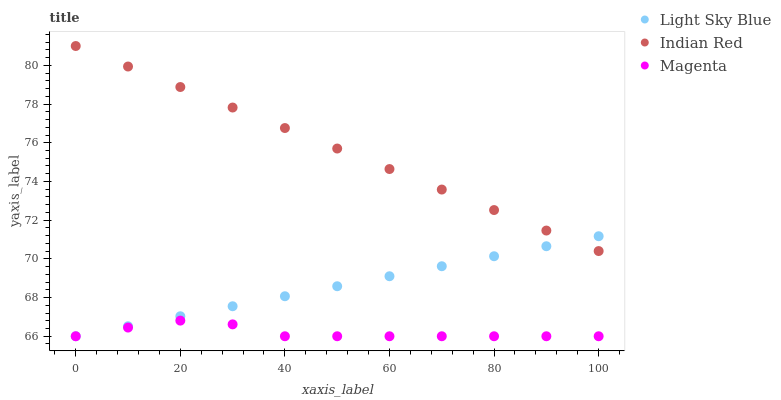Does Magenta have the minimum area under the curve?
Answer yes or no. Yes. Does Indian Red have the maximum area under the curve?
Answer yes or no. Yes. Does Light Sky Blue have the minimum area under the curve?
Answer yes or no. No. Does Light Sky Blue have the maximum area under the curve?
Answer yes or no. No. Is Light Sky Blue the smoothest?
Answer yes or no. Yes. Is Magenta the roughest?
Answer yes or no. Yes. Is Indian Red the smoothest?
Answer yes or no. No. Is Indian Red the roughest?
Answer yes or no. No. Does Magenta have the lowest value?
Answer yes or no. Yes. Does Indian Red have the lowest value?
Answer yes or no. No. Does Indian Red have the highest value?
Answer yes or no. Yes. Does Light Sky Blue have the highest value?
Answer yes or no. No. Is Magenta less than Indian Red?
Answer yes or no. Yes. Is Indian Red greater than Magenta?
Answer yes or no. Yes. Does Light Sky Blue intersect Magenta?
Answer yes or no. Yes. Is Light Sky Blue less than Magenta?
Answer yes or no. No. Is Light Sky Blue greater than Magenta?
Answer yes or no. No. Does Magenta intersect Indian Red?
Answer yes or no. No. 